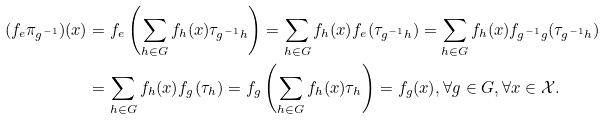<formula> <loc_0><loc_0><loc_500><loc_500>( f _ { e } \pi _ { g ^ { - 1 } } ) ( x ) & = f _ { e } \left ( \sum _ { h \in G } f _ { h } ( x ) \tau _ { g ^ { - 1 } h } \right ) = \sum _ { h \in G } f _ { h } ( x ) f _ { e } ( \tau _ { g ^ { - 1 } h } ) = \sum _ { h \in G } f _ { h } ( x ) f _ { g ^ { - 1 } g } ( \tau _ { g ^ { - 1 } h } ) \\ & = \sum _ { h \in G } f _ { h } ( x ) f _ { g } ( \tau _ { h } ) = f _ { g } \left ( \sum _ { h \in G } f _ { h } ( x ) \tau _ { h } \right ) = f _ { g } ( x ) , \forall g \in G , \forall x \in \mathcal { X } .</formula> 